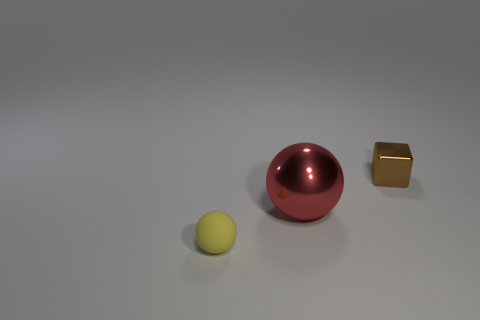Add 2 brown metallic blocks. How many objects exist? 5 Subtract 0 cyan cubes. How many objects are left? 3 Subtract all cubes. How many objects are left? 2 Subtract all large yellow objects. Subtract all tiny things. How many objects are left? 1 Add 3 yellow rubber spheres. How many yellow rubber spheres are left? 4 Add 2 small things. How many small things exist? 4 